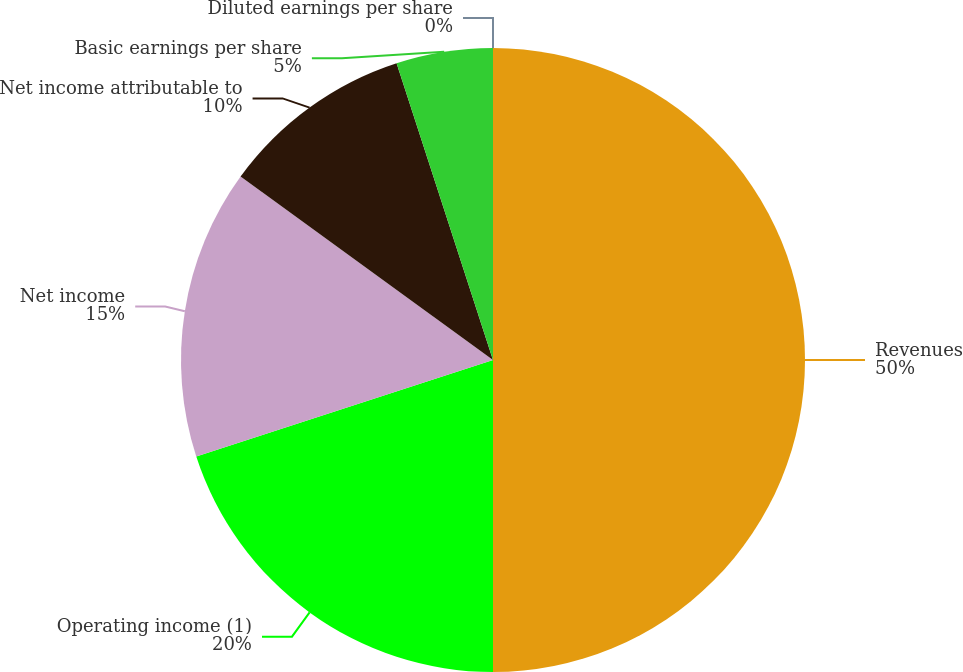Convert chart to OTSL. <chart><loc_0><loc_0><loc_500><loc_500><pie_chart><fcel>Revenues<fcel>Operating income (1)<fcel>Net income<fcel>Net income attributable to<fcel>Basic earnings per share<fcel>Diluted earnings per share<nl><fcel>50.0%<fcel>20.0%<fcel>15.0%<fcel>10.0%<fcel>5.0%<fcel>0.0%<nl></chart> 